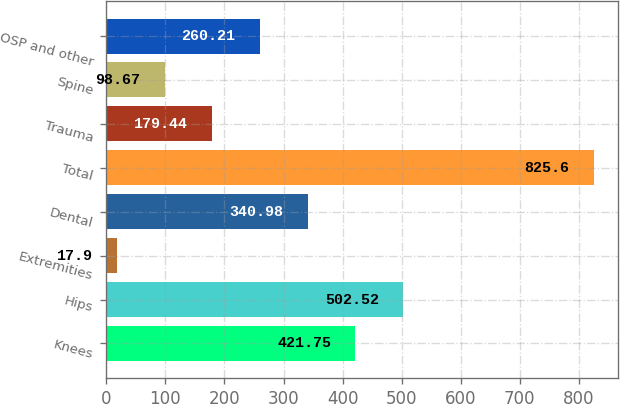Convert chart. <chart><loc_0><loc_0><loc_500><loc_500><bar_chart><fcel>Knees<fcel>Hips<fcel>Extremities<fcel>Dental<fcel>Total<fcel>Trauma<fcel>Spine<fcel>OSP and other<nl><fcel>421.75<fcel>502.52<fcel>17.9<fcel>340.98<fcel>825.6<fcel>179.44<fcel>98.67<fcel>260.21<nl></chart> 